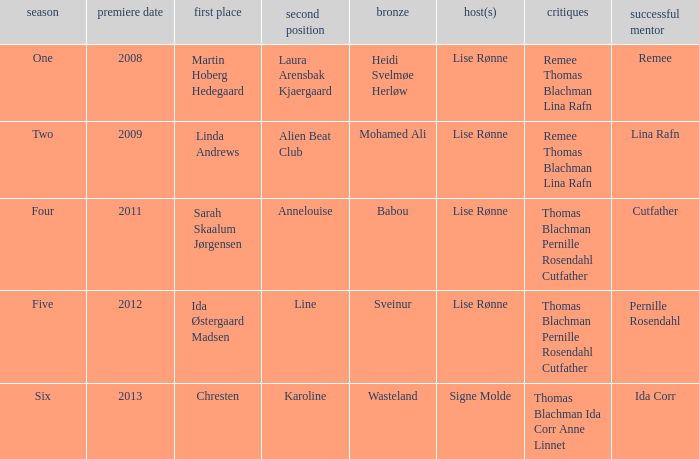Who was the runner-up in season five? Line. 